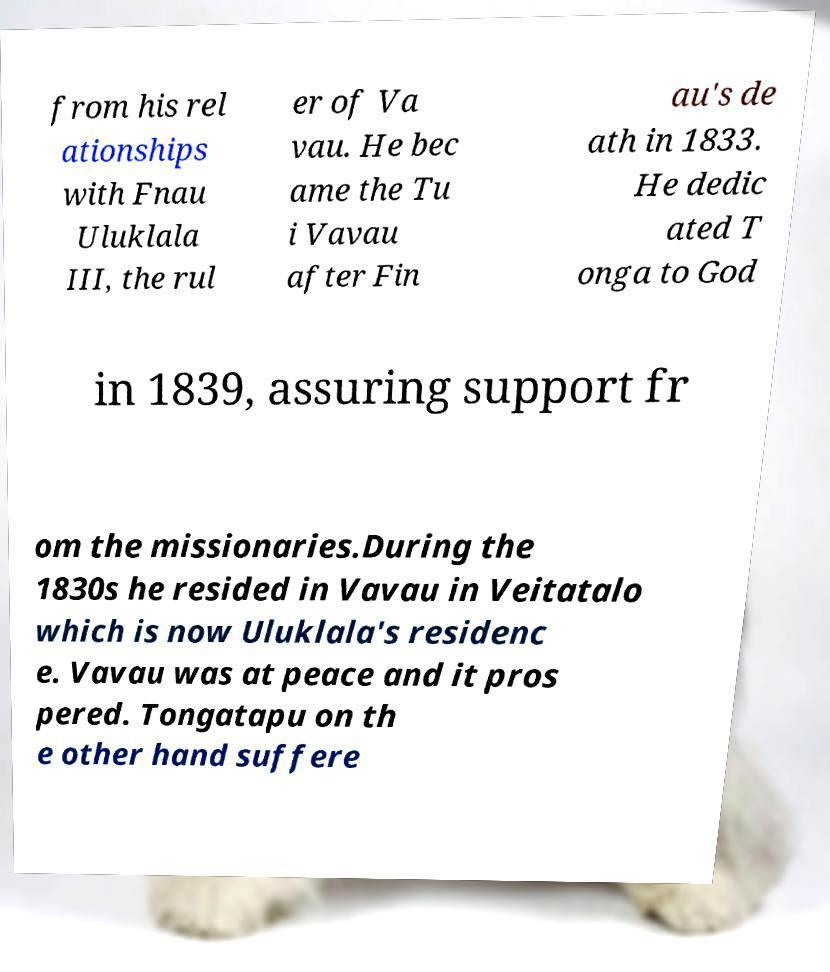Could you extract and type out the text from this image? from his rel ationships with Fnau Uluklala III, the rul er of Va vau. He bec ame the Tu i Vavau after Fin au's de ath in 1833. He dedic ated T onga to God in 1839, assuring support fr om the missionaries.During the 1830s he resided in Vavau in Veitatalo which is now Uluklala's residenc e. Vavau was at peace and it pros pered. Tongatapu on th e other hand suffere 